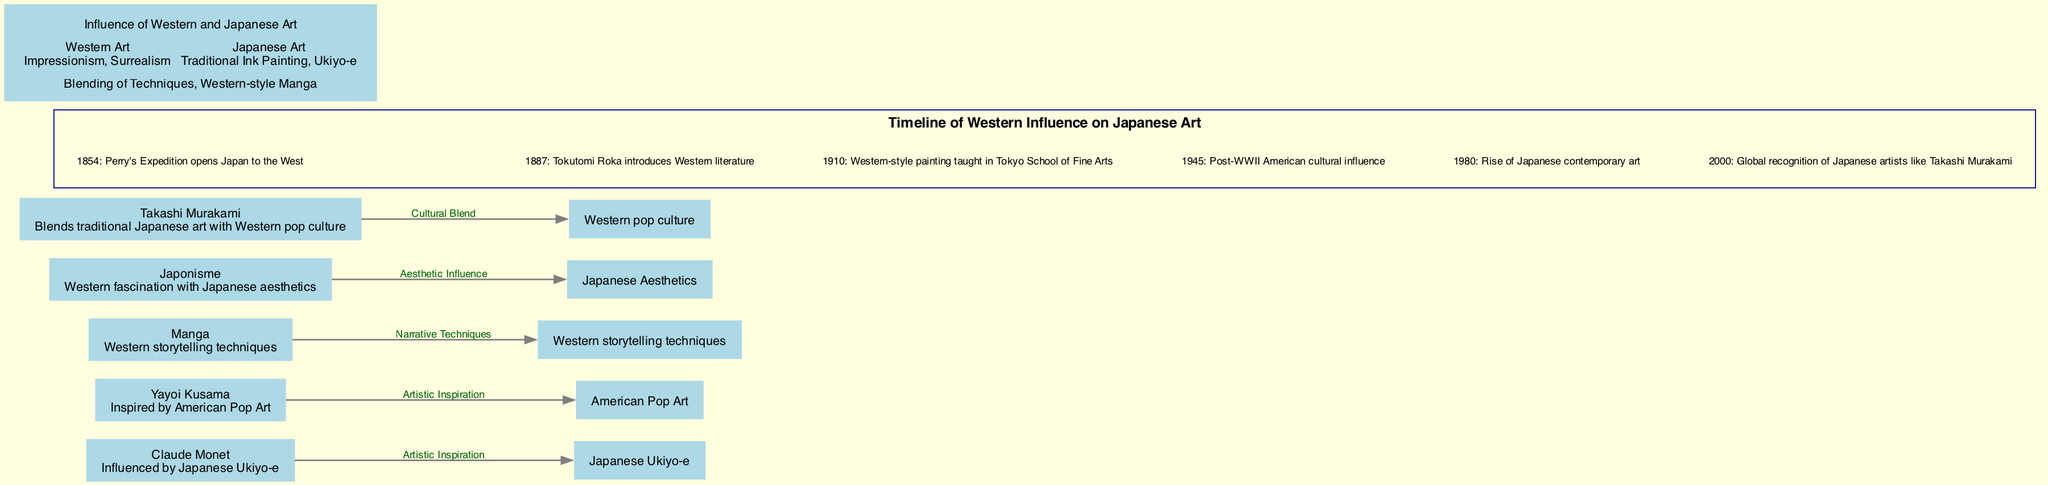What are the two categories in the Venn diagram? The Venn diagram lists two categories: "Western Art" and "Japanese Art." These are clearly labeled at the top of their respective sections.
Answer: Western Art, Japanese Art What is one influence of Western art mentioned in the Venn diagram? In the Venn diagram under "Western Art," it specifically mentions "Impressionism" as an influence from Western art.
Answer: Impressionism What event occurred in 1945 on the historical timeline? According to the historical timeline, the event that took place in 1945 is "Post-WWII American cultural influence." This is noted as a significant event impacting Japanese art.
Answer: Post-WWII American cultural influence How many artists are listed in the cross-cultural influence map? The cross-cultural influence map features five artists or concepts, each contributing to the influence between Japan and the West. By counting, you can confirm this total.
Answer: 5 Which artist is described as blending traditional Japanese art with Western pop culture? In the cross-cultural influence map, Takashi Murakami is explicitly described as blending traditional Japanese art with Western pop culture, highlighting his unique fusion style.
Answer: Takashi Murakami How many events are mentioned in the historical timeline? The historical timeline lists six specific events, each with a year and a descriptive event. Counting them in succession reveals this total.
Answer: 6 What aesthetic influence does Japonisme represent? Japonisme is described in the cross-cultural influence map as representing "Western fascination with Japanese aesthetics," indicating a cultural appreciation that influenced Western art.
Answer: Western fascination with Japanese aesthetics Which artist is noted for being inspired by American Pop Art? Yayoi Kusama is identified in the cross-cultural influence map as being inspired by American Pop Art, showcasing cross-cultural artistic influence.
Answer: Yayoi Kusama What is a shared feature of both Western and Japanese art mentioned in the Venn diagram? In the Venn diagram's intersection area, it highlights "Blending of Techniques" as a shared feature, indicating the integration of elements from both art forms.
Answer: Blending of Techniques 